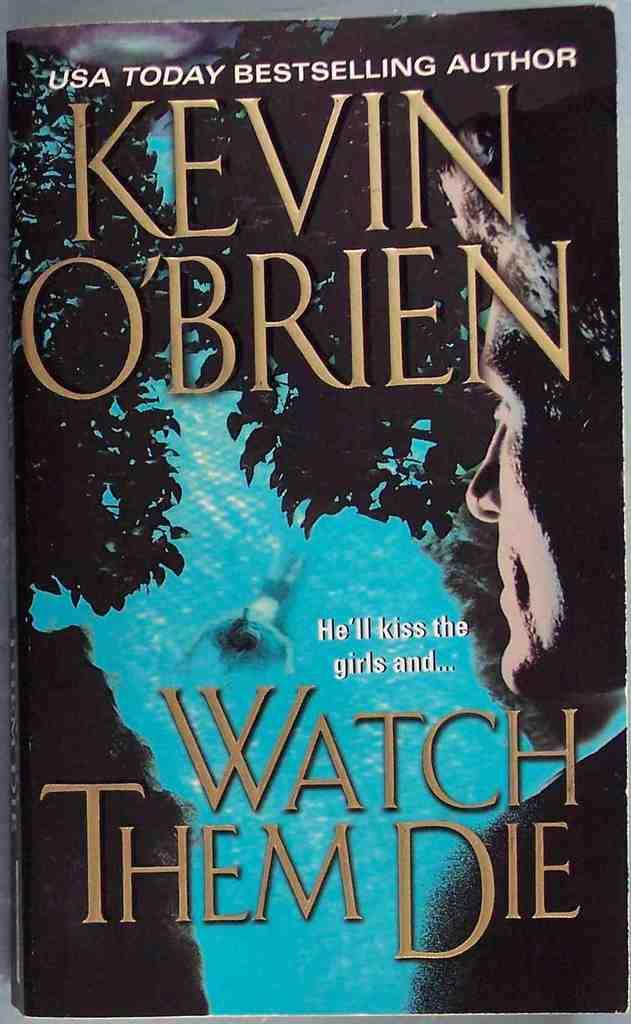<image>
Present a compact description of the photo's key features. A copy of the book Watch Them Die by Kevin O'Brien. 